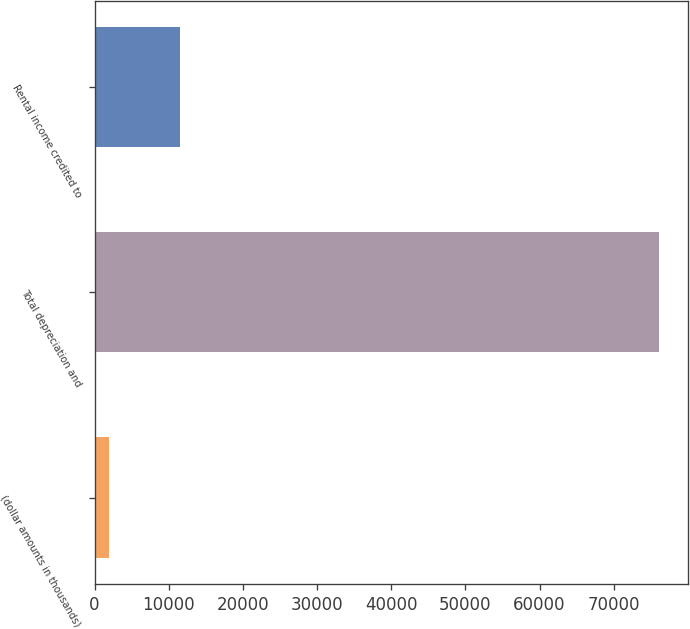Convert chart to OTSL. <chart><loc_0><loc_0><loc_500><loc_500><bar_chart><fcel>(dollar amounts in thousands)<fcel>Total depreciation and<fcel>Rental income credited to<nl><fcel>2012<fcel>76170<fcel>11519<nl></chart> 